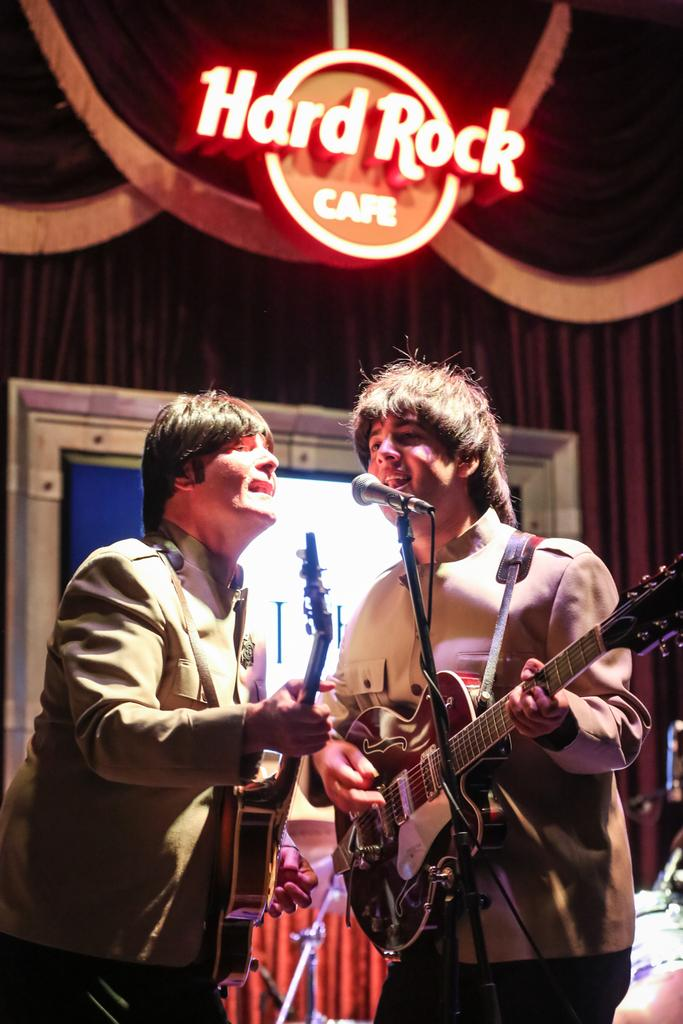How many people are in the image? There are two persons in the image. What are the persons doing in the image? The persons are playing guitar. What object is in front of the persons? There is a microphone in front of the persons. What can be seen in the background of the image? There is a screen and a curtain in the background of the image. What is at the top of the image? There is a logo at the top of the image. Can you tell me how many icicles are hanging from the curtain in the image? There are no icicles present in the image; it features a curtain in the background. What type of paint is used on the logo at the top of the image? There is no information about the type of paint used on the logo in the image. 